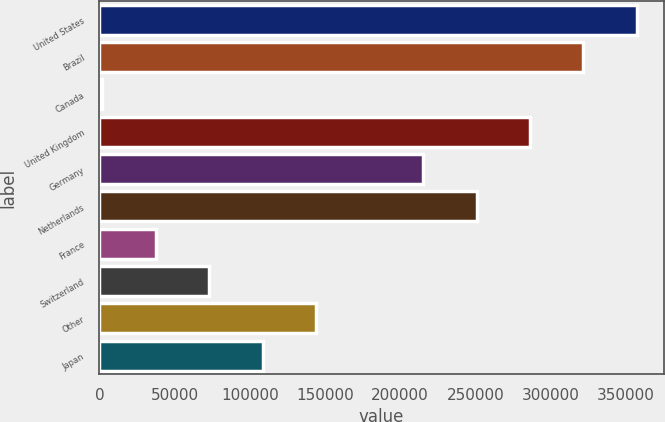Convert chart to OTSL. <chart><loc_0><loc_0><loc_500><loc_500><bar_chart><fcel>United States<fcel>Brazil<fcel>Canada<fcel>United Kingdom<fcel>Germany<fcel>Netherlands<fcel>France<fcel>Switzerland<fcel>Other<fcel>Japan<nl><fcel>357422<fcel>321878<fcel>1977<fcel>286333<fcel>215244<fcel>250788<fcel>37521.5<fcel>73066<fcel>144155<fcel>108610<nl></chart> 